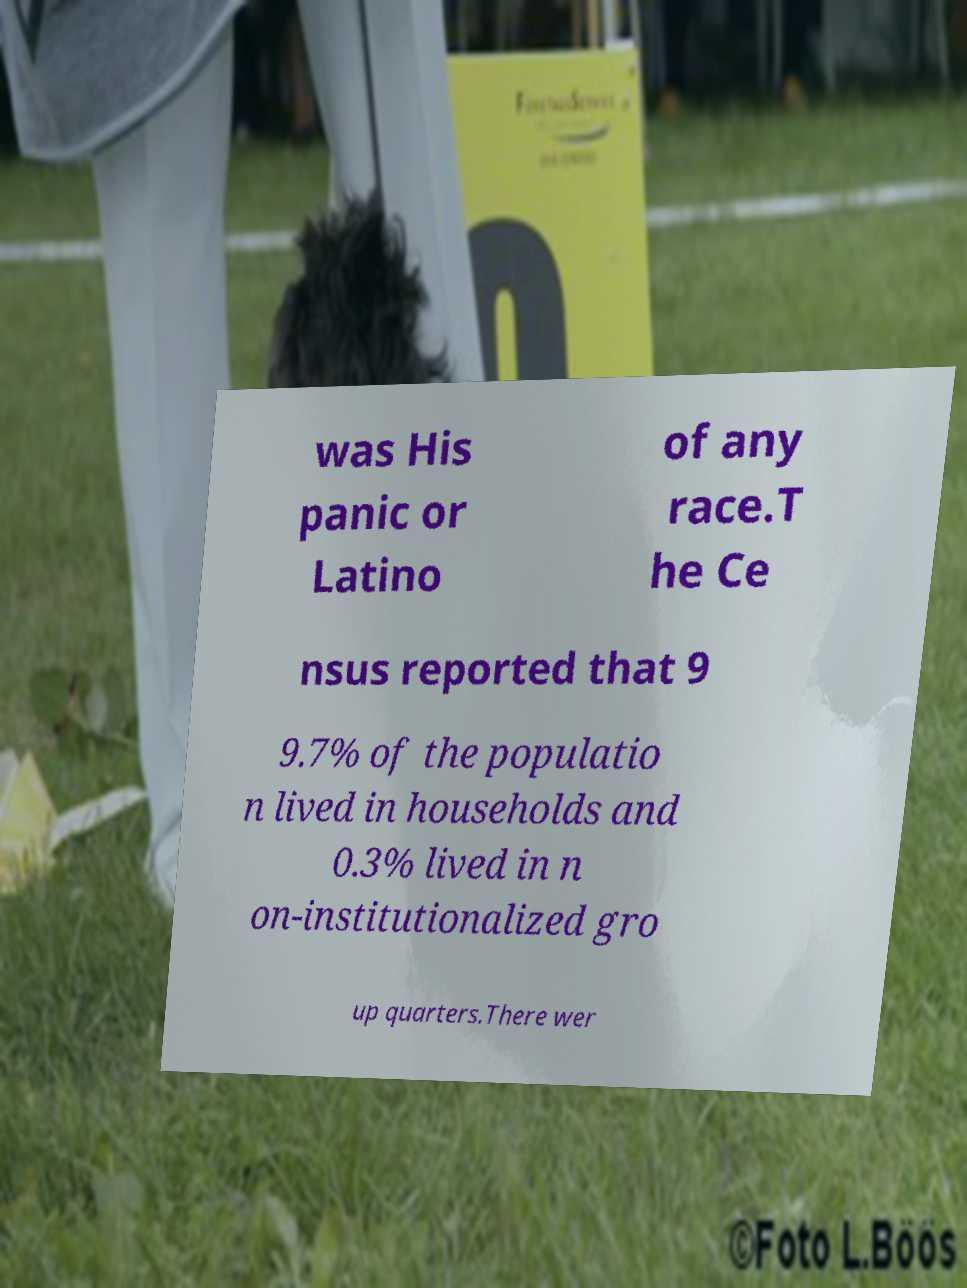Could you extract and type out the text from this image? was His panic or Latino of any race.T he Ce nsus reported that 9 9.7% of the populatio n lived in households and 0.3% lived in n on-institutionalized gro up quarters.There wer 